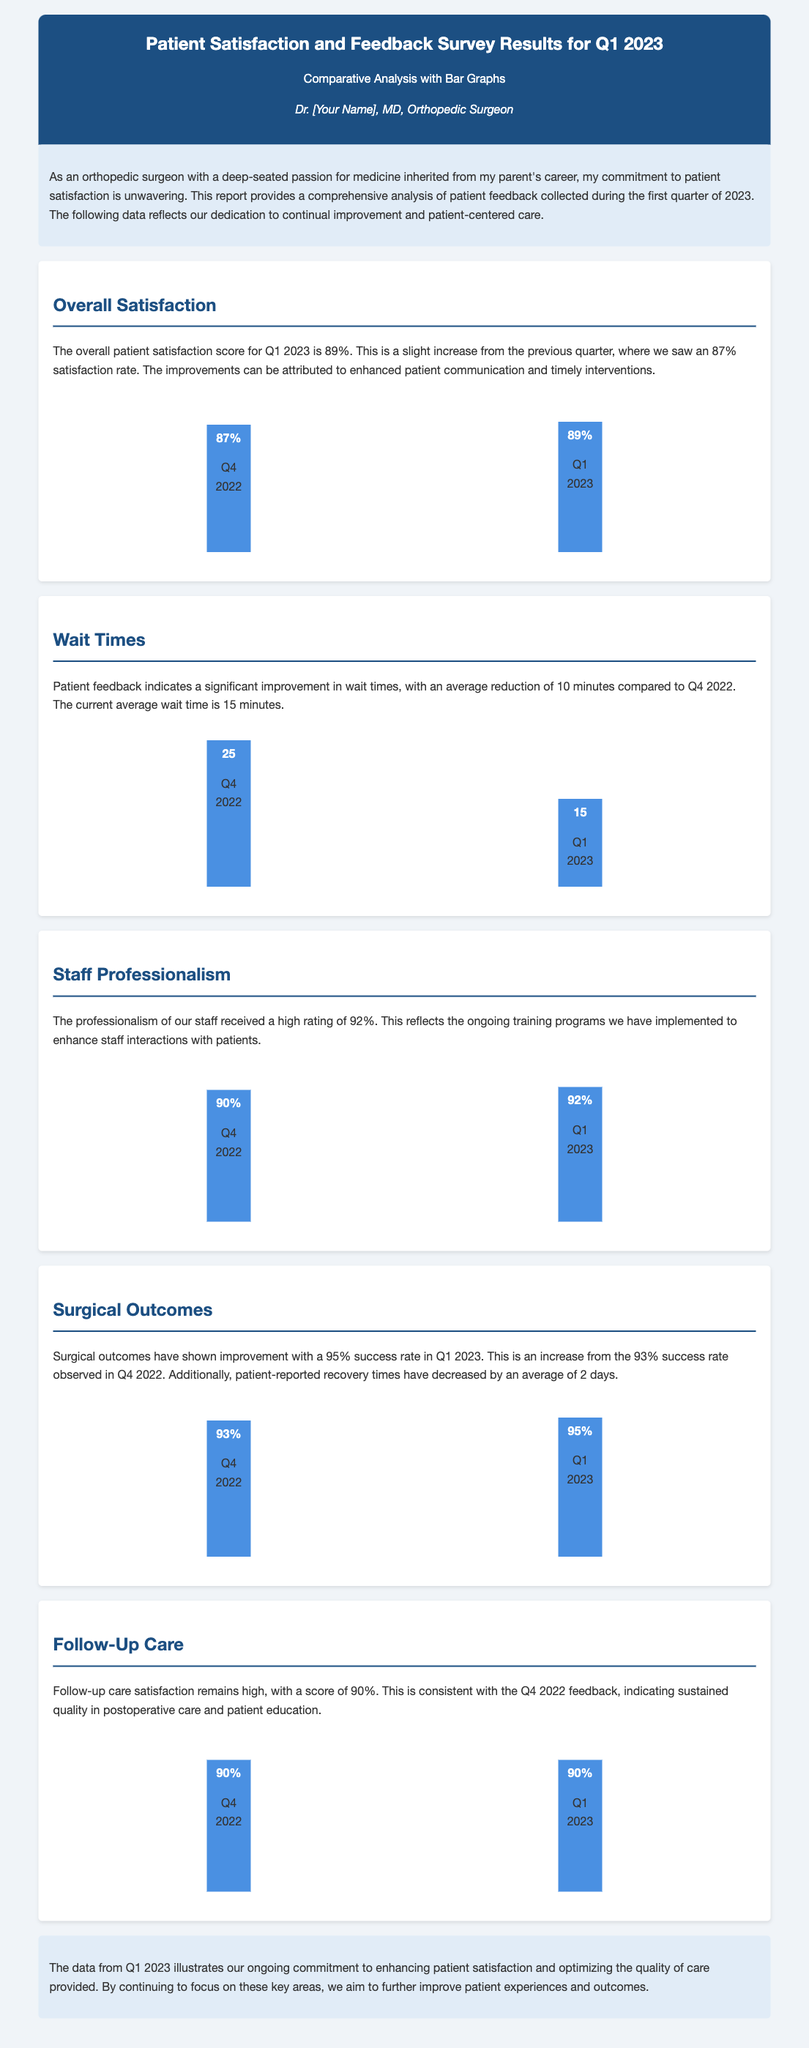What was the overall patient satisfaction score for Q1 2023? The overall patient satisfaction score for Q1 2023 is mentioned as 89%.
Answer: 89% What was the average wait time in Q1 2023? The document states that the average wait time in Q1 2023 is 15 minutes.
Answer: 15 minutes What percentage rating did staff professionalism receive? The rating for staff professionalism in Q1 2023 is listed as 92%.
Answer: 92% What was the success rate of surgical outcomes in Q4 2022? The success rate of surgical outcomes in Q4 2022 is given as 93%.
Answer: 93% How much did the average wait time decrease from Q4 2022 to Q1 2023? The document notes a reduction of 10 minutes in wait times from Q4 2022 to Q1 2023.
Answer: 10 minutes What is the follow-up care satisfaction score for Q1 2023? Follow-up care satisfaction for Q1 2023 is documented as 90%.
Answer: 90% What was the increase in the overall satisfaction score from Q4 2022 to Q1 2023? Overall satisfaction increased from 87% in Q4 2022 to 89% in Q1 2023, resulting in a 2% increase.
Answer: 2% What were the patient-reported recovery times’ average decrease in Q1 2023? The document indicates an average decrease in recovery times by 2 days in Q1 2023.
Answer: 2 days 